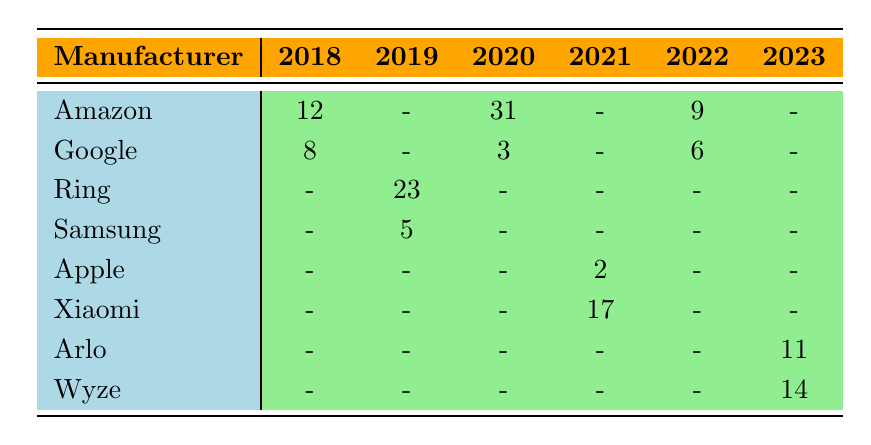What is the total number of incidents reported by Amazon across all years? To find the total incidents reported by Amazon, we look at the rows corresponding to Amazon: in 2018 there are 12 incidents, in 2020 there are 31 incidents, and in 2022 there are 9 incidents. Adding these values together gives us 12 + 31 + 9 = 52.
Answer: 52 Which manufacturer had the highest number of incidents in 2019? In 2019, the manufacturers and their incidents are: Ring with 23 incidents and Samsung with 5 incidents. Ring has the higher value, so it had the highest number of incidents in that year.
Answer: Ring Did Apple report any incidents in the years 2018 and 2020? Checking the table, we see that Apple had no entries in both 2018 and 2020, meaning there were no reported incidents for those years.
Answer: No What is the average number of incidents reported by Google across the years? Google had incidents reported in 2018 (8), 2020 (3), and 2022 (6). To find the average, sum these values which gives us 8 + 3 + 6 = 17, and there are 3 years of data, so the average is 17/3 = approximately 5.67.
Answer: 5.67 In which year did Xiaomi report the largest number of incidents? According to the table, Xiaomi reported 17 incidents in 2021 and did not report incidents in other years. Therefore, 2021 was the year with the largest number of reported incidents for Xiaomi.
Answer: 2021 Was there an increase in the number of reported incidents from 2019 to 2020 for Ring? Looking at Ring's data, in 2019 they reported 23 incidents, while in 2020 there were no reported incidents. Since 23 (2019) is greater than 0 (2020), there was actually a decrease, not an increase.
Answer: No What is the total number of incidents reported for unauthorized access across all manufacturers and years? The incidents categorized as unauthorized access are from Ring (23 in 2019), Amazon (31 in 2020), Xiaomi (17 in 2021), Echo Show (9 in 2022), and Wyze (14 in 2023). Summing these gives us 23 + 31 + 17 + 9 + 14 = 94 incidents.
Answer: 94 Is it true that all manufacturers reported incidents in 2022? By inspecting the table, we see that in 2022, only Amazon and Google reported incidents (9 and 6, respectively), while Ring, Samsung, Apple, Xiaomi, Arlo, and Wyze had no entries. Therefore, it is not true that all manufacturers reported incidents that year.
Answer: No Which manufacturer reported the least number of incidents in the year 2021? From the table, in 2021, the reported incidents are: Apple (2) and Xiaomi (17). Apple has the least number of incidents as 2 is lower than 17.
Answer: Apple 